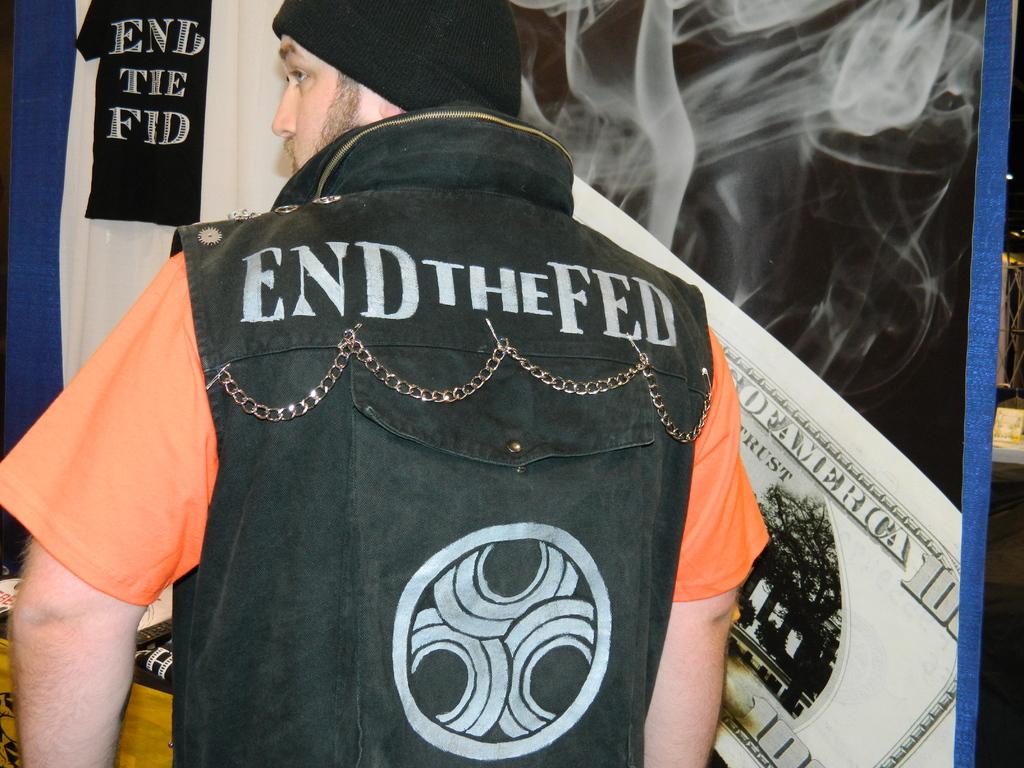What is the last word on the bill behind the man?
Provide a succinct answer. America. 